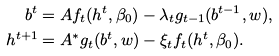Convert formula to latex. <formula><loc_0><loc_0><loc_500><loc_500>b ^ { t } & = A f _ { t } ( h ^ { t } , \beta _ { 0 } ) - \lambda _ { t } g _ { t - 1 } ( b ^ { t - 1 } , w ) , \\ h ^ { t + 1 } & = A ^ { * } g _ { t } ( b ^ { t } , w ) - \xi _ { t } f _ { t } ( h ^ { t } , \beta _ { 0 } ) .</formula> 